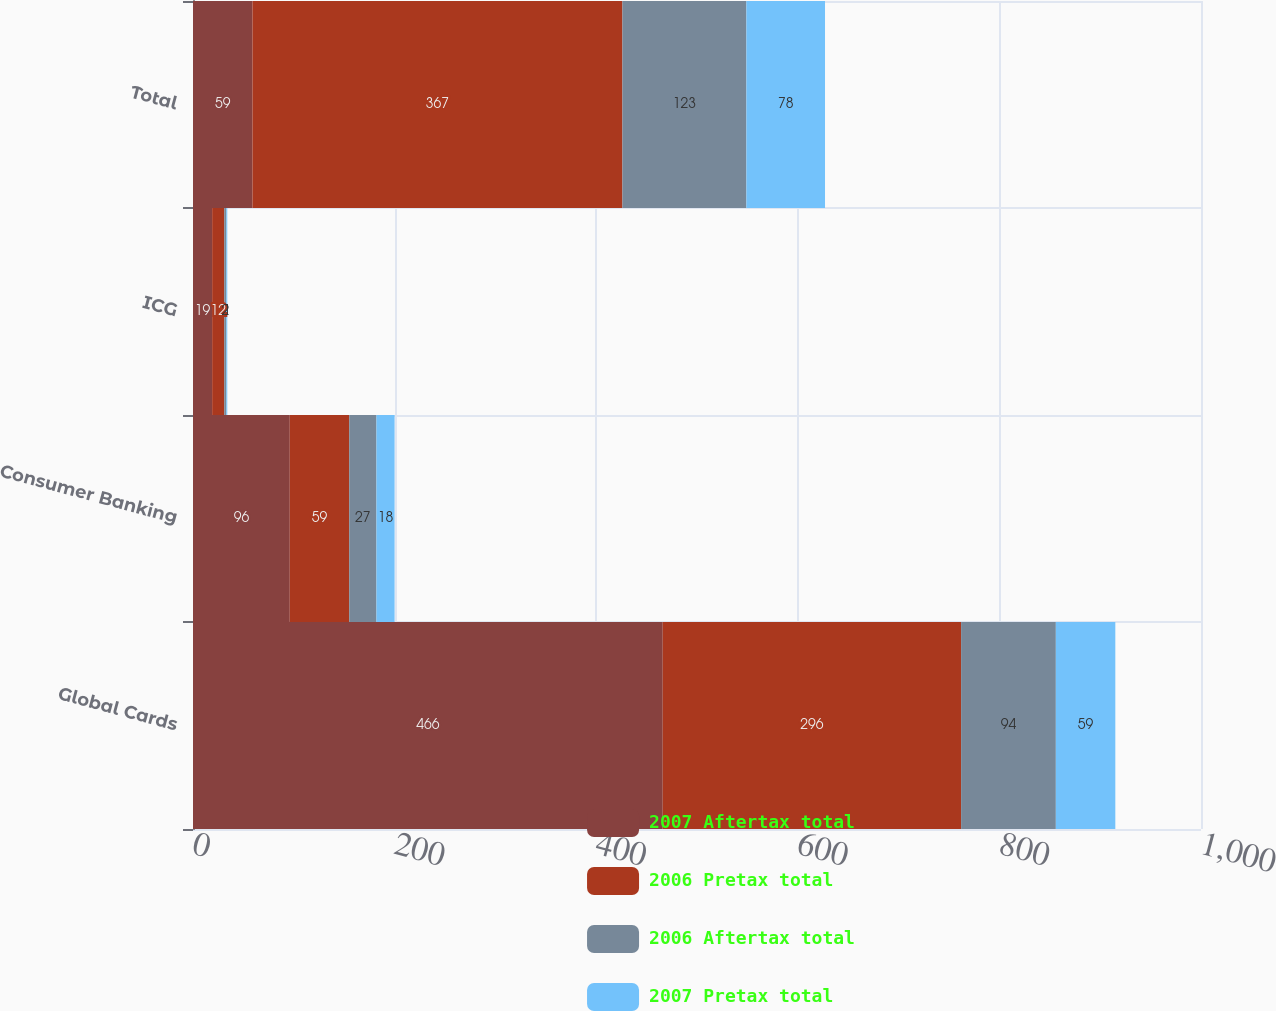<chart> <loc_0><loc_0><loc_500><loc_500><stacked_bar_chart><ecel><fcel>Global Cards<fcel>Consumer Banking<fcel>ICG<fcel>Total<nl><fcel>2007 Aftertax total<fcel>466<fcel>96<fcel>19<fcel>59<nl><fcel>2006 Pretax total<fcel>296<fcel>59<fcel>12<fcel>367<nl><fcel>2006 Aftertax total<fcel>94<fcel>27<fcel>2<fcel>123<nl><fcel>2007 Pretax total<fcel>59<fcel>18<fcel>1<fcel>78<nl></chart> 